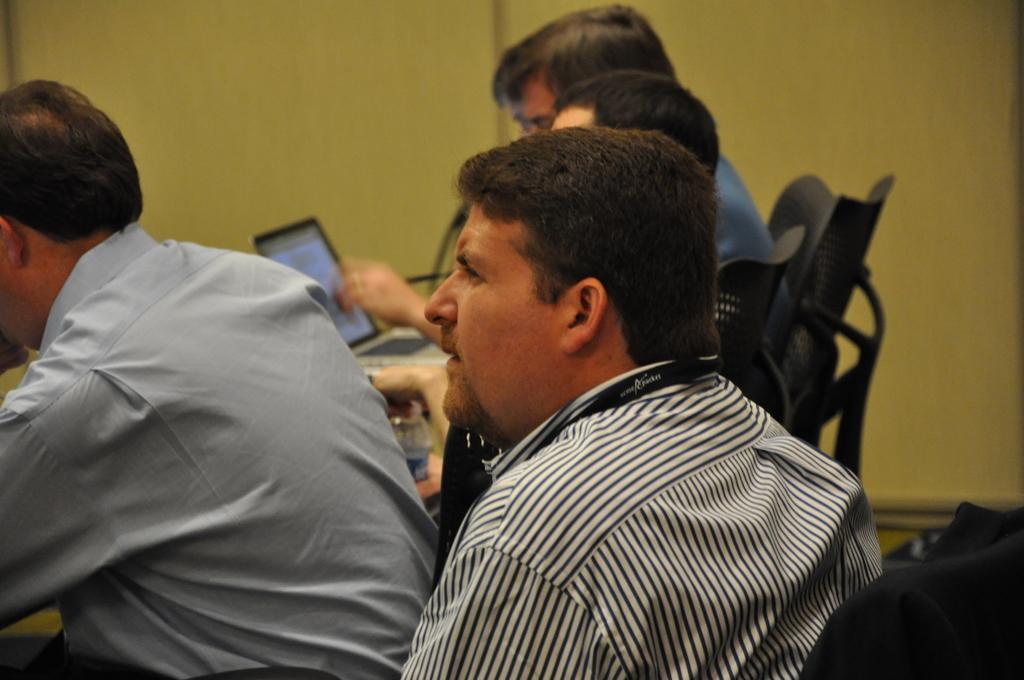How would you summarize this image in a sentence or two? There are four persons sitting on the chairs. Here we can see a laptop and a bottle. In the background there is a wall. 